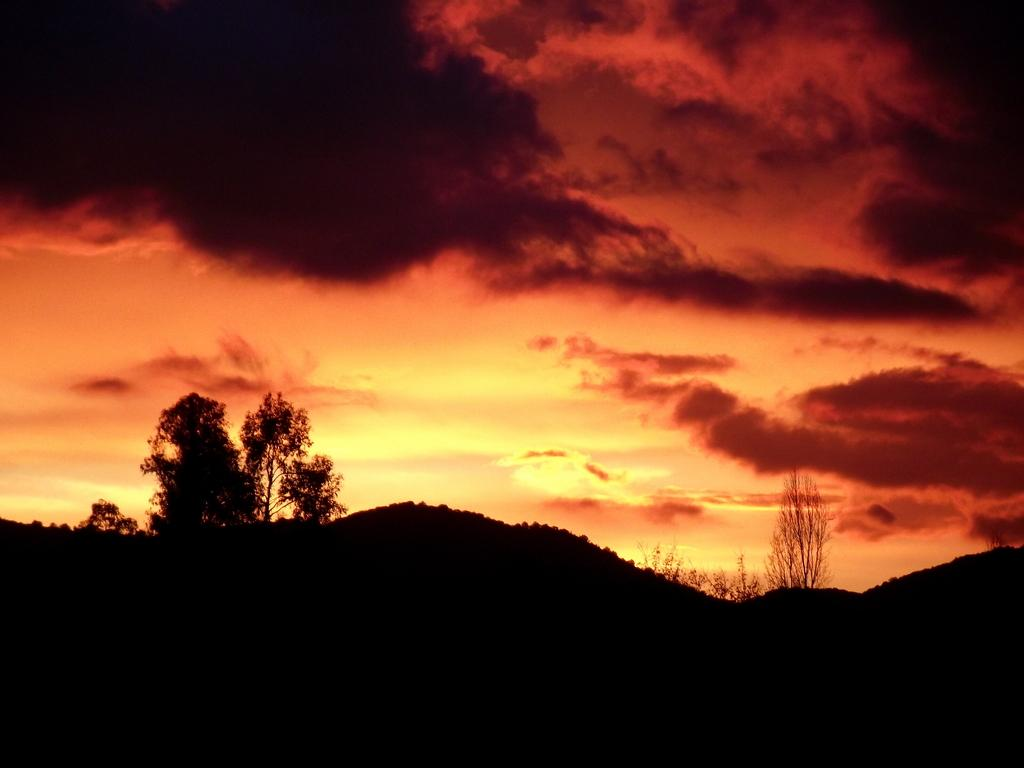What is visible in the sky in the image? The sky with clouds is visible in the image. What type of vegetation can be seen in the image? There are trees in the image. What type of natural landform is present in the image? There are hills in the image. Can you see a parent holding a child near the trees in the image? There is no parent or child present in the image; it only features the sky, trees, and hills. What type of structure is visible on top of the hills in the image? There is no structure visible on top of the hills in the image. 